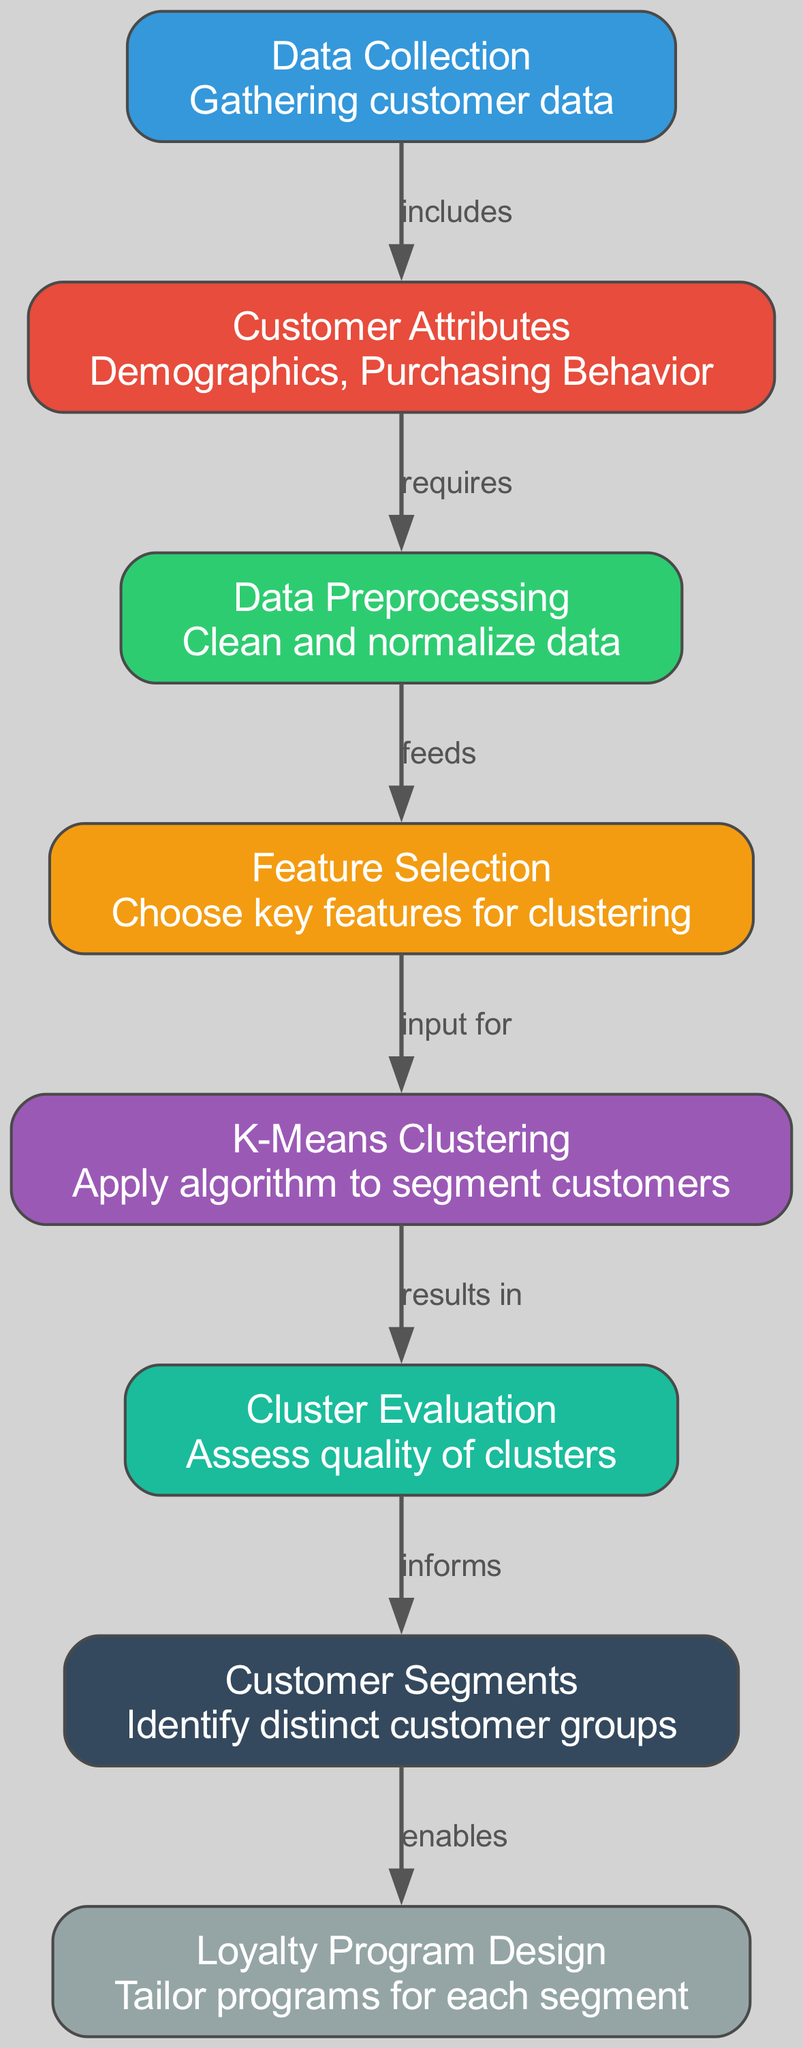what is the total number of nodes in the diagram? There are eight nodes listed in the data under the "nodes" key, which represent different steps in the customer segmentation process.
Answer: 8 what are the attributes included in the "Customer Attributes" node? The "Customer Attributes" node contains demographics and purchasing behavior, as described in the node's information.
Answer: Demographics, Purchasing Behavior which node comes after "Data Preprocessing"? The "Feature Selection" node follows "Data Preprocessing" in the sequence, according to the edges connecting these nodes.
Answer: Feature Selection what type of algorithm is applied in the "K-Means Clustering" node? The node explicitly states the use of the K-Means algorithm for segmenting customers.
Answer: K-Means how does "Cluster Evaluation" relate to "K-Means Clustering"? "Cluster Evaluation" is a result of the "K-Means Clustering" process as indicated by the direction of the edge connecting these two nodes (results in).
Answer: results in which node is the final step in the customer segmentation process? The final step is "Loyalty Program Design," as it is the last node listed after the customer segmentation processes have been completed.
Answer: Loyalty Program Design what does the "Feature Selection" node provide input for? The "Feature Selection" node provides critical input for the "K-Means Clustering" node, which uses the selected features to perform customer segmentation.
Answer: input for which node informs "Customer Segments"? The "Cluster Evaluation" node informs the "Customer Segments" node, indicating how the quality of clusters affects the identification of distinct groups.
Answer: Cluster Evaluation 